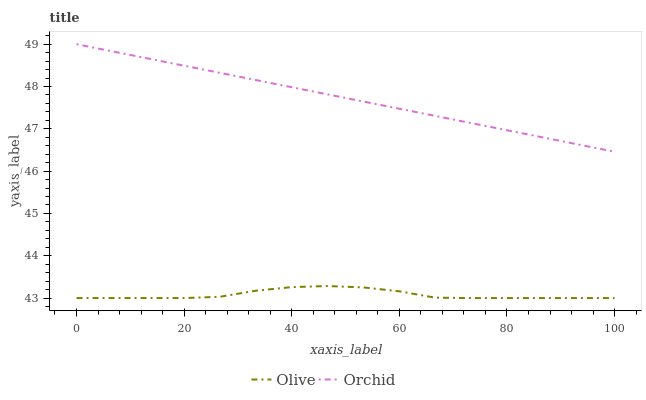Does Orchid have the minimum area under the curve?
Answer yes or no. No. Is Orchid the roughest?
Answer yes or no. No. Does Orchid have the lowest value?
Answer yes or no. No. Is Olive less than Orchid?
Answer yes or no. Yes. Is Orchid greater than Olive?
Answer yes or no. Yes. Does Olive intersect Orchid?
Answer yes or no. No. 